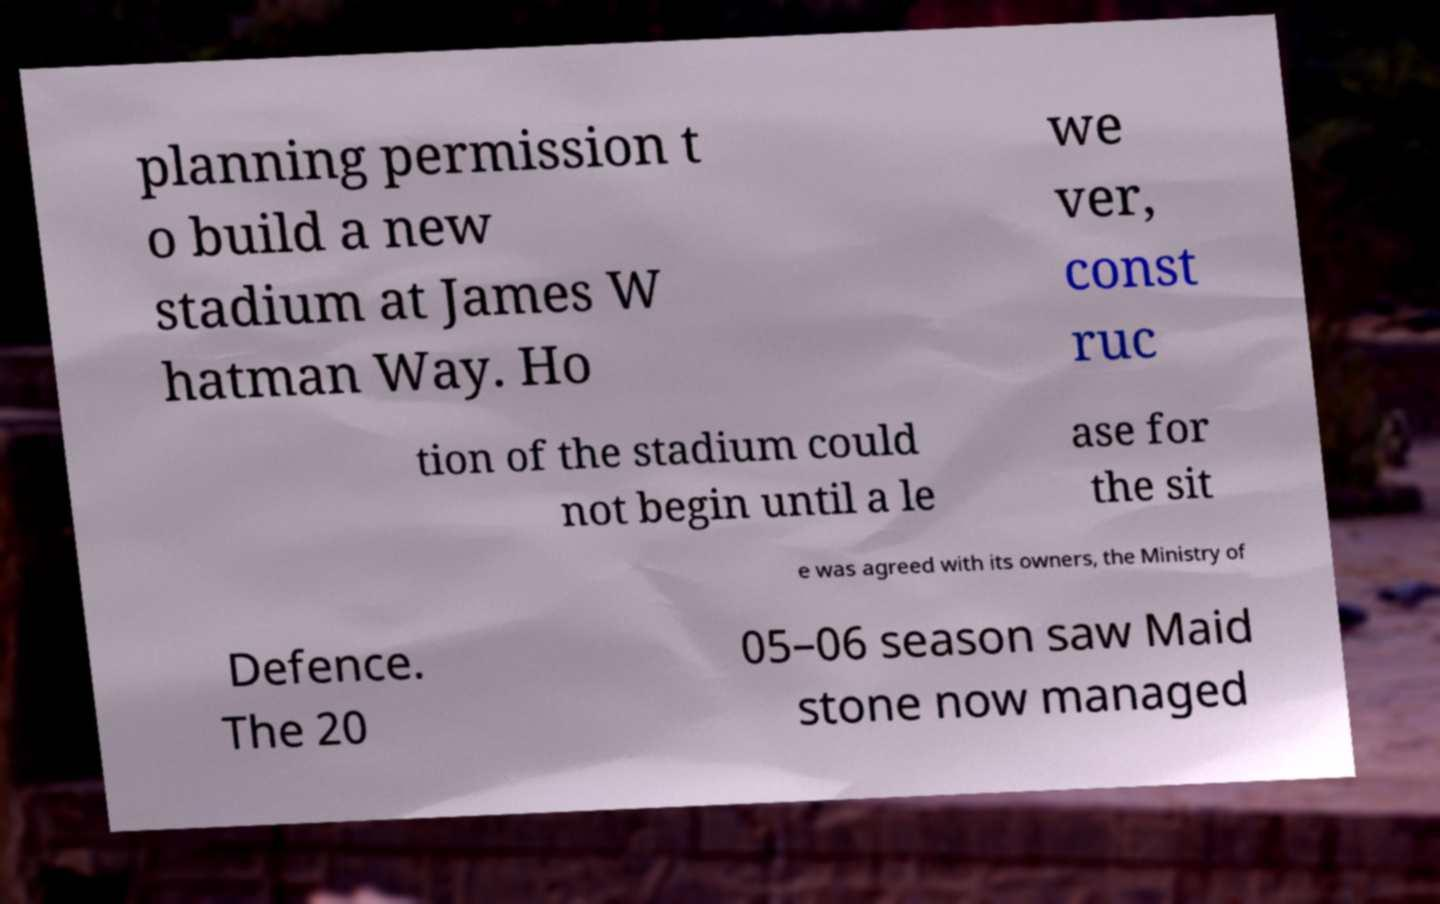Can you read and provide the text displayed in the image?This photo seems to have some interesting text. Can you extract and type it out for me? planning permission t o build a new stadium at James W hatman Way. Ho we ver, const ruc tion of the stadium could not begin until a le ase for the sit e was agreed with its owners, the Ministry of Defence. The 20 05–06 season saw Maid stone now managed 